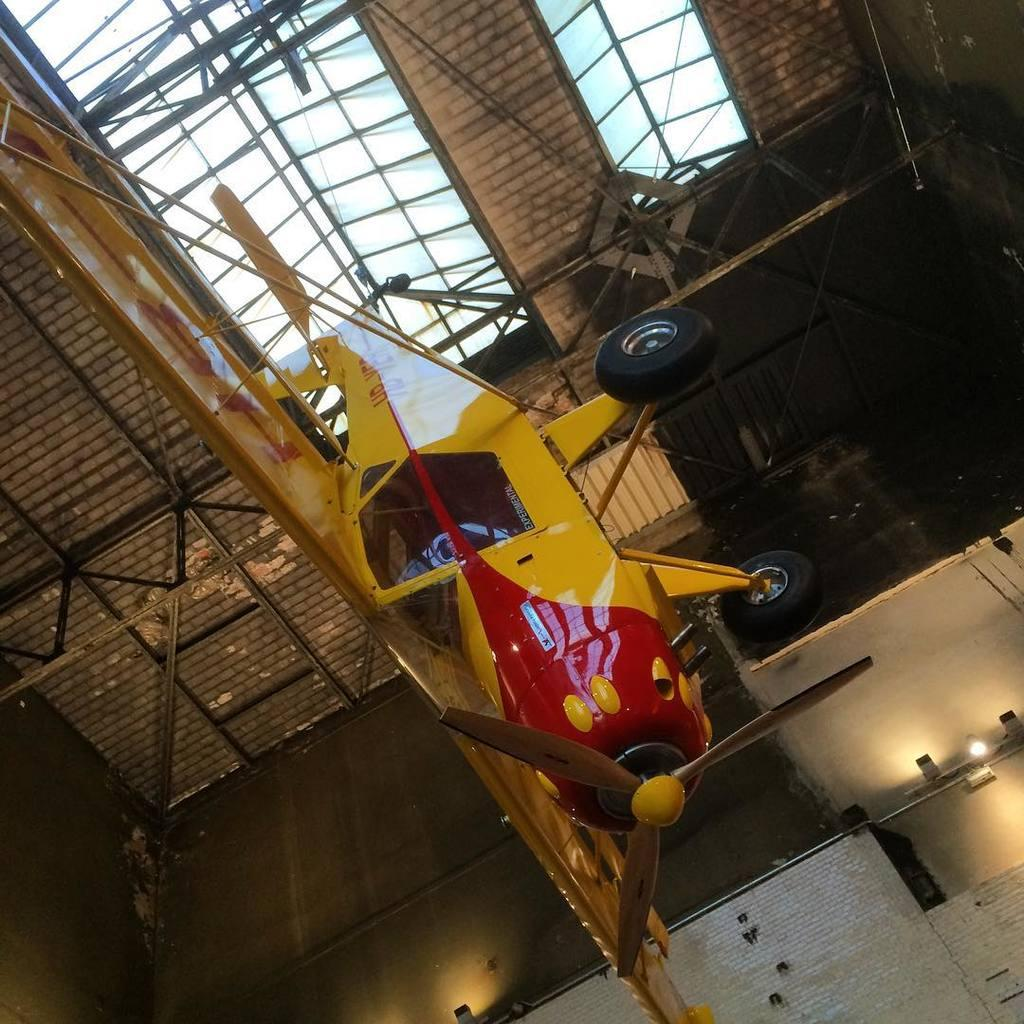What type of vehicle is in the picture? There is a small aircraft in the picture. What colors are visible on the aircraft? The aircraft has red and yellow colors. How is the aircraft positioned in the image? The aircraft is hanging from the ceiling. What materials can be seen in the image? There is an iron frame and glass in the image. What type of pets are visible in the image? There are no pets visible in the image. What interests are represented by the items in the image? The image does not convey any specific interests; it simply shows a small aircraft hanging from the ceiling. 